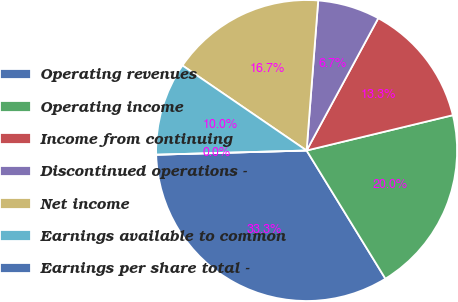Convert chart. <chart><loc_0><loc_0><loc_500><loc_500><pie_chart><fcel>Operating revenues<fcel>Operating income<fcel>Income from continuing<fcel>Discontinued operations -<fcel>Net income<fcel>Earnings available to common<fcel>Earnings per share total -<nl><fcel>33.33%<fcel>20.0%<fcel>13.33%<fcel>6.67%<fcel>16.67%<fcel>10.0%<fcel>0.0%<nl></chart> 